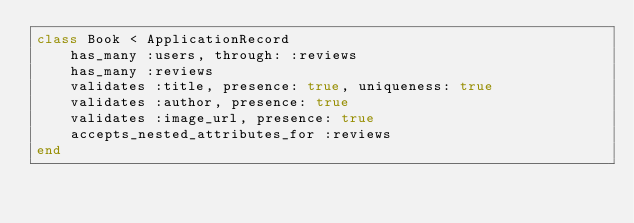<code> <loc_0><loc_0><loc_500><loc_500><_Ruby_>class Book < ApplicationRecord
    has_many :users, through: :reviews
    has_many :reviews
    validates :title, presence: true, uniqueness: true
    validates :author, presence: true
    validates :image_url, presence: true
    accepts_nested_attributes_for :reviews
end
</code> 